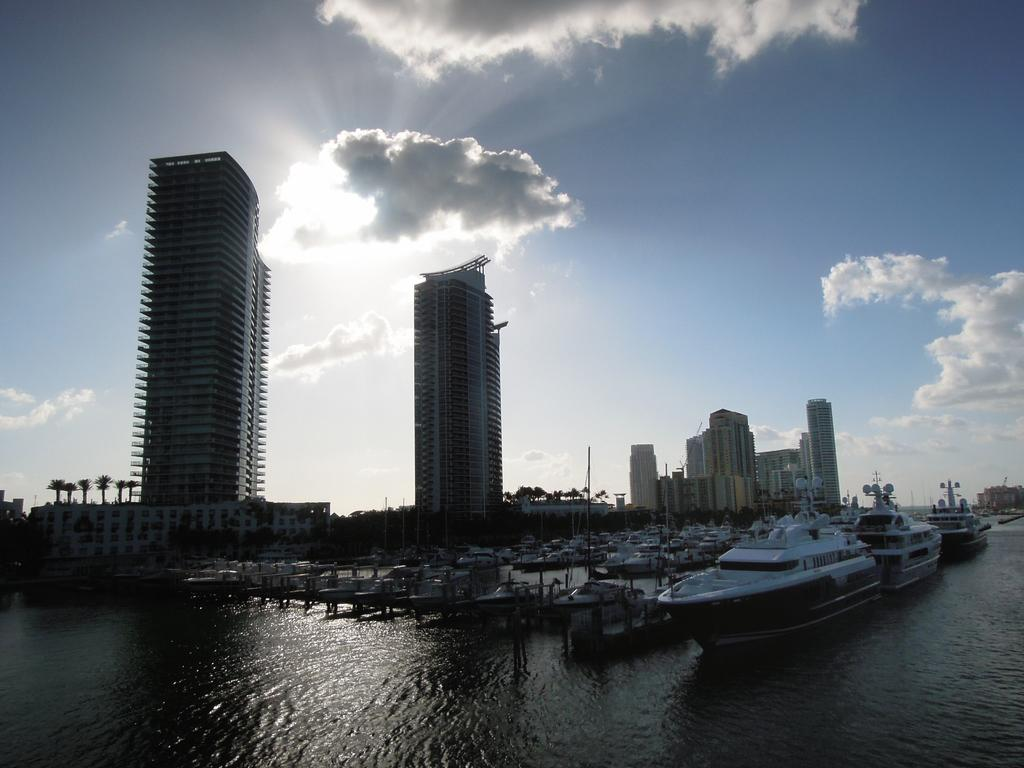What type of structures can be seen in the image? There are buildings in the image. What type of vehicles are present in the water? There are ships and boats in the image. What is the water used for in the image? The water is visible in the image, but its specific purpose is not mentioned. What is visible in the sky? The sky is visible in the image, and clouds are present. What type of government is depicted in the image? There is no indication of a government in the image; it features buildings, ships, boats, water, and sky. Can you compare the size of the cemetery to the buildings in the image? There is no cemetery present in the image; it features buildings, ships, boats, water, and sky. 